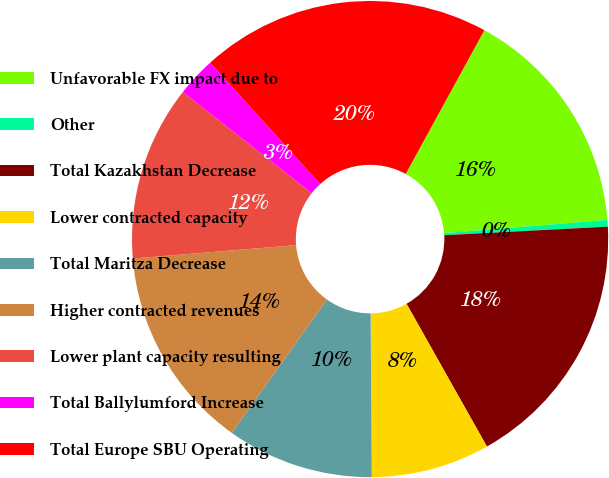<chart> <loc_0><loc_0><loc_500><loc_500><pie_chart><fcel>Unfavorable FX impact due to<fcel>Other<fcel>Total Kazakhstan Decrease<fcel>Lower contracted capacity<fcel>Total Maritza Decrease<fcel>Higher contracted revenues<fcel>Lower plant capacity resulting<fcel>Total Ballylumford Increase<fcel>Total Europe SBU Operating<nl><fcel>15.75%<fcel>0.45%<fcel>17.67%<fcel>8.05%<fcel>9.98%<fcel>13.83%<fcel>11.9%<fcel>2.68%<fcel>19.69%<nl></chart> 